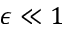Convert formula to latex. <formula><loc_0><loc_0><loc_500><loc_500>\epsilon \ll 1</formula> 